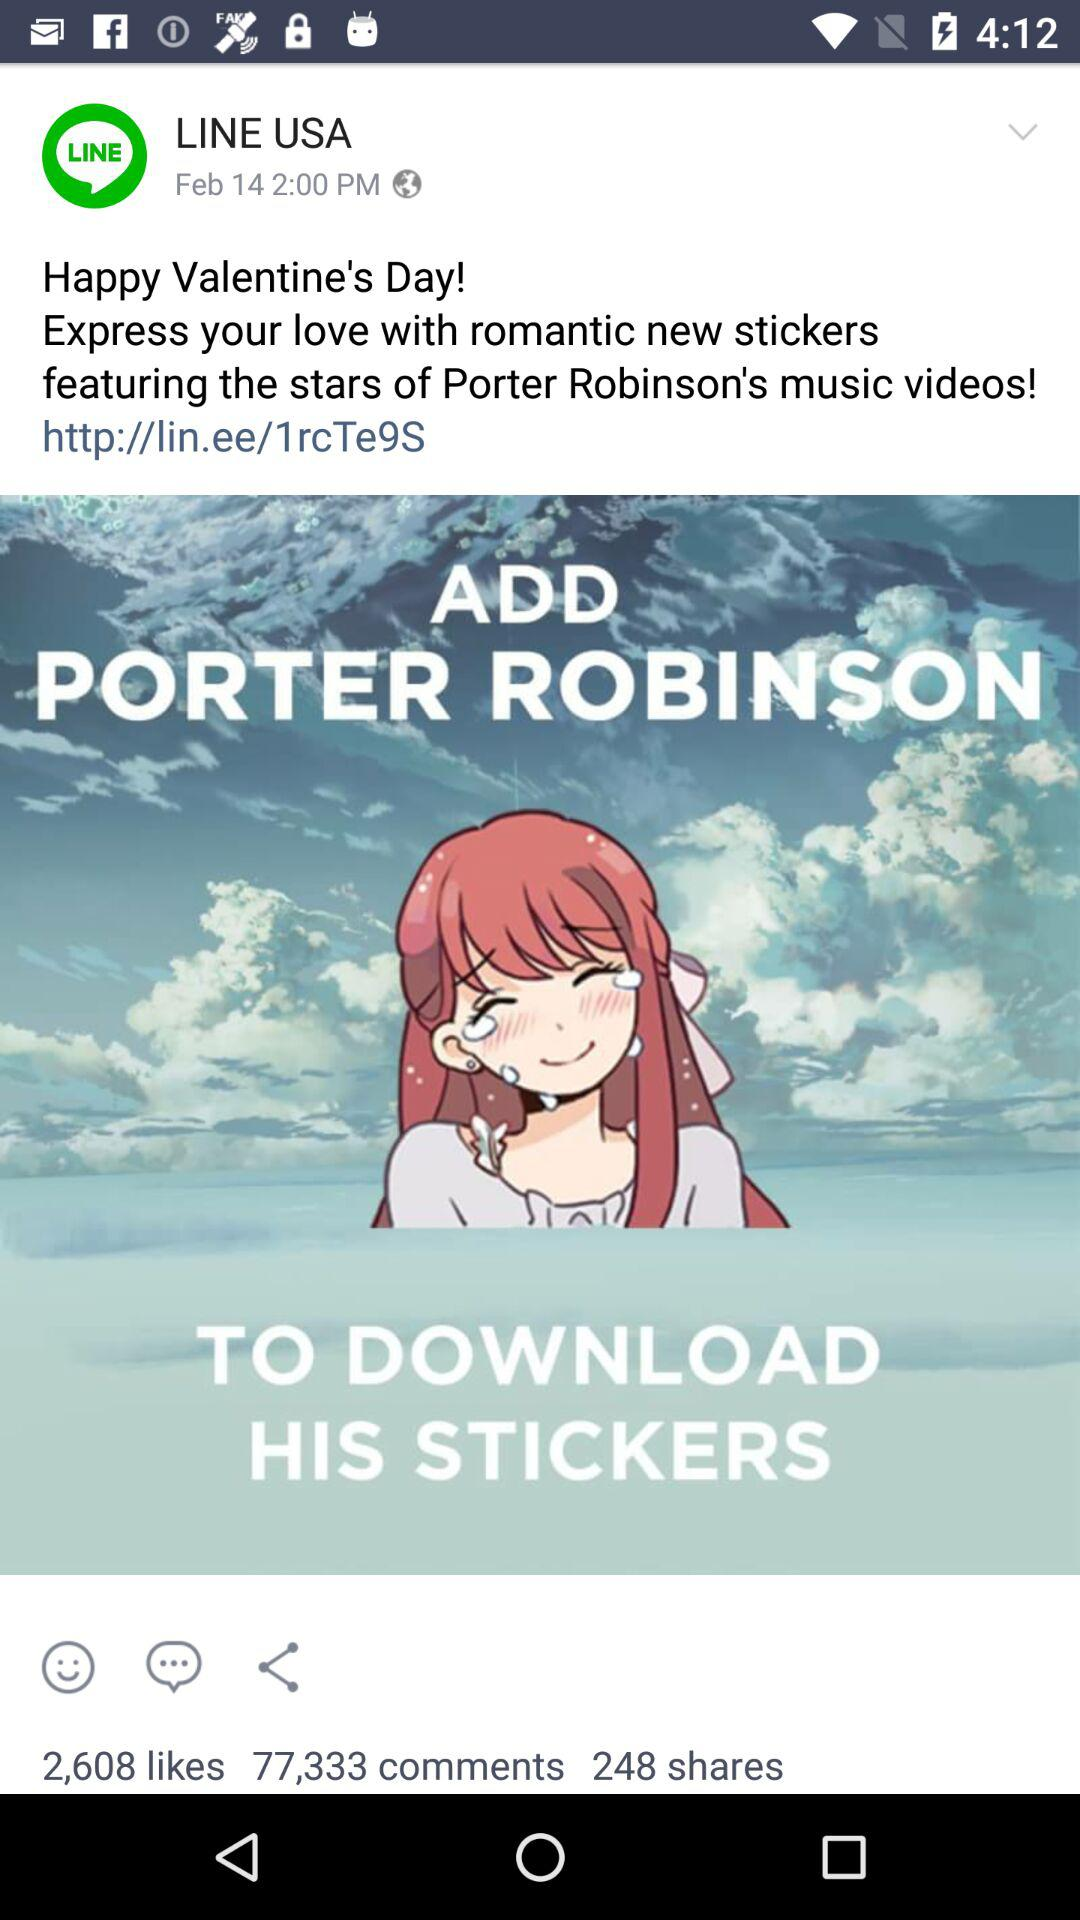How many more comments are there than likes?
Answer the question using a single word or phrase. 74725 